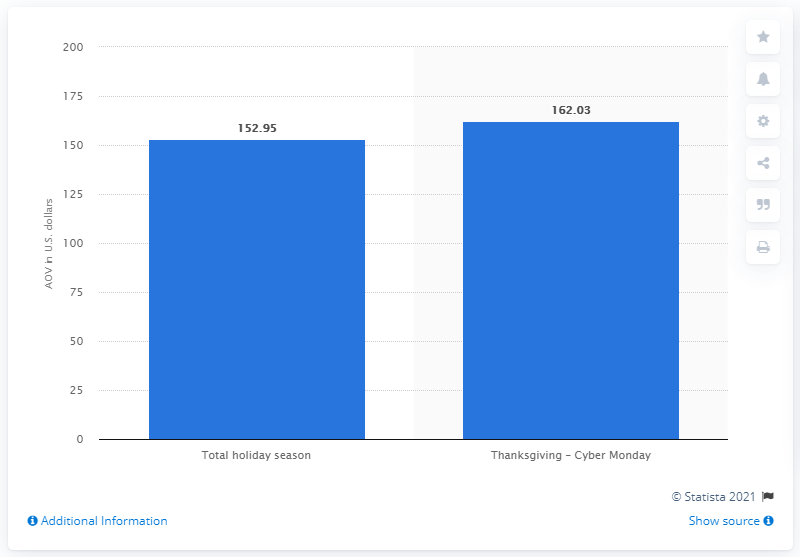Mention a couple of crucial points in this snapshot. During the Thanksgiving to Cyber Monday weekend, the average value of e-commerce orders was 162.03. The average order value during the November to December period was 152.95. 